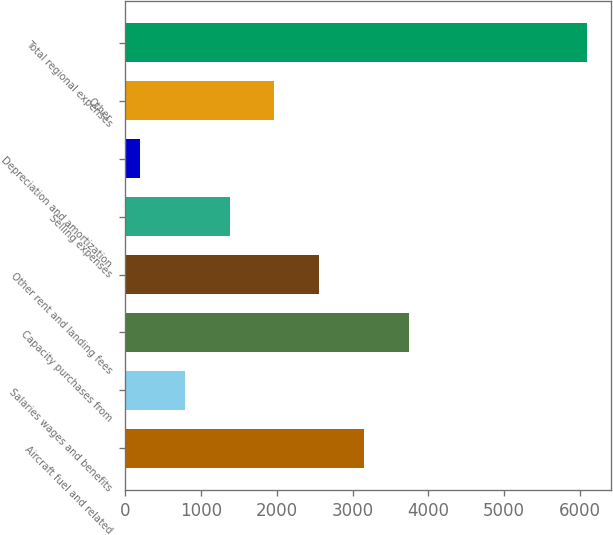Convert chart. <chart><loc_0><loc_0><loc_500><loc_500><bar_chart><fcel>Aircraft fuel and related<fcel>Salaries wages and benefits<fcel>Capacity purchases from<fcel>Other rent and landing fees<fcel>Selling expenses<fcel>Depreciation and amortization<fcel>Other<fcel>Total regional expenses<nl><fcel>3147.5<fcel>787.1<fcel>3737.6<fcel>2557.4<fcel>1377.2<fcel>197<fcel>1967.3<fcel>6098<nl></chart> 